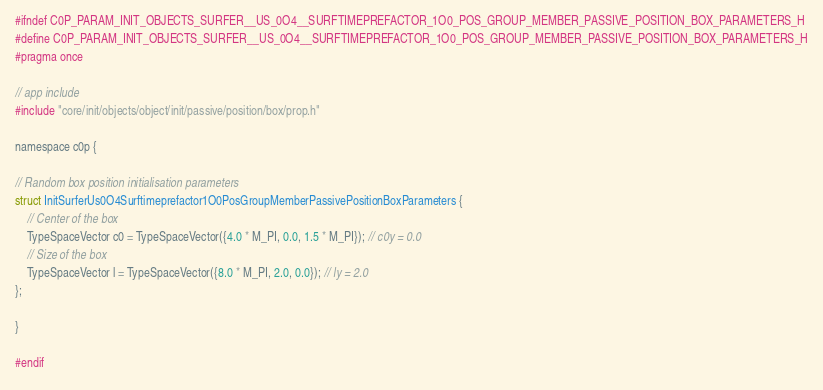<code> <loc_0><loc_0><loc_500><loc_500><_C_>#ifndef C0P_PARAM_INIT_OBJECTS_SURFER__US_0O4__SURFTIMEPREFACTOR_1O0_POS_GROUP_MEMBER_PASSIVE_POSITION_BOX_PARAMETERS_H
#define C0P_PARAM_INIT_OBJECTS_SURFER__US_0O4__SURFTIMEPREFACTOR_1O0_POS_GROUP_MEMBER_PASSIVE_POSITION_BOX_PARAMETERS_H
#pragma once

// app include
#include "core/init/objects/object/init/passive/position/box/prop.h"

namespace c0p {

// Random box position initialisation parameters
struct InitSurferUs0O4Surftimeprefactor1O0PosGroupMemberPassivePositionBoxParameters {
    // Center of the box
    TypeSpaceVector c0 = TypeSpaceVector({4.0 * M_PI, 0.0, 1.5 * M_PI}); // c0y = 0.0
    // Size of the box
    TypeSpaceVector l = TypeSpaceVector({8.0 * M_PI, 2.0, 0.0}); // ly = 2.0
};

}

#endif
</code> 